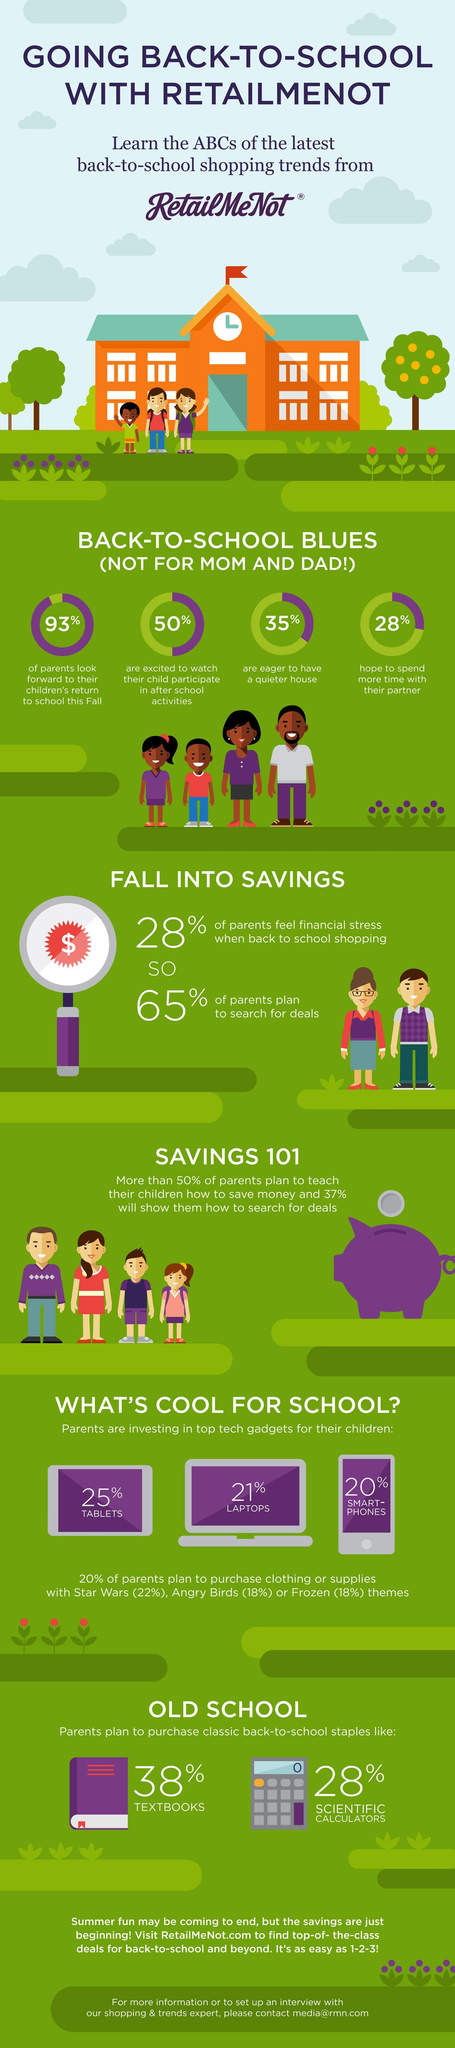List a handful of essential elements in this visual. According to the survey, 35% of parents expressed a strong desire for a quieter home environment. According to the survey, 18% of parents are planning to purchase clothing or supplies with a Frozen theme for their children. According to a recent survey, 22% of parents plan to purchase clothing or supplies with a Star Wars theme for their children. According to the survey, 18% of parents plan on purchasing clothing or supplies with an Angry Birds theme for their children. According to the survey, 20% of parents are planning to purchase clothing or supplies with a theme for their children. 